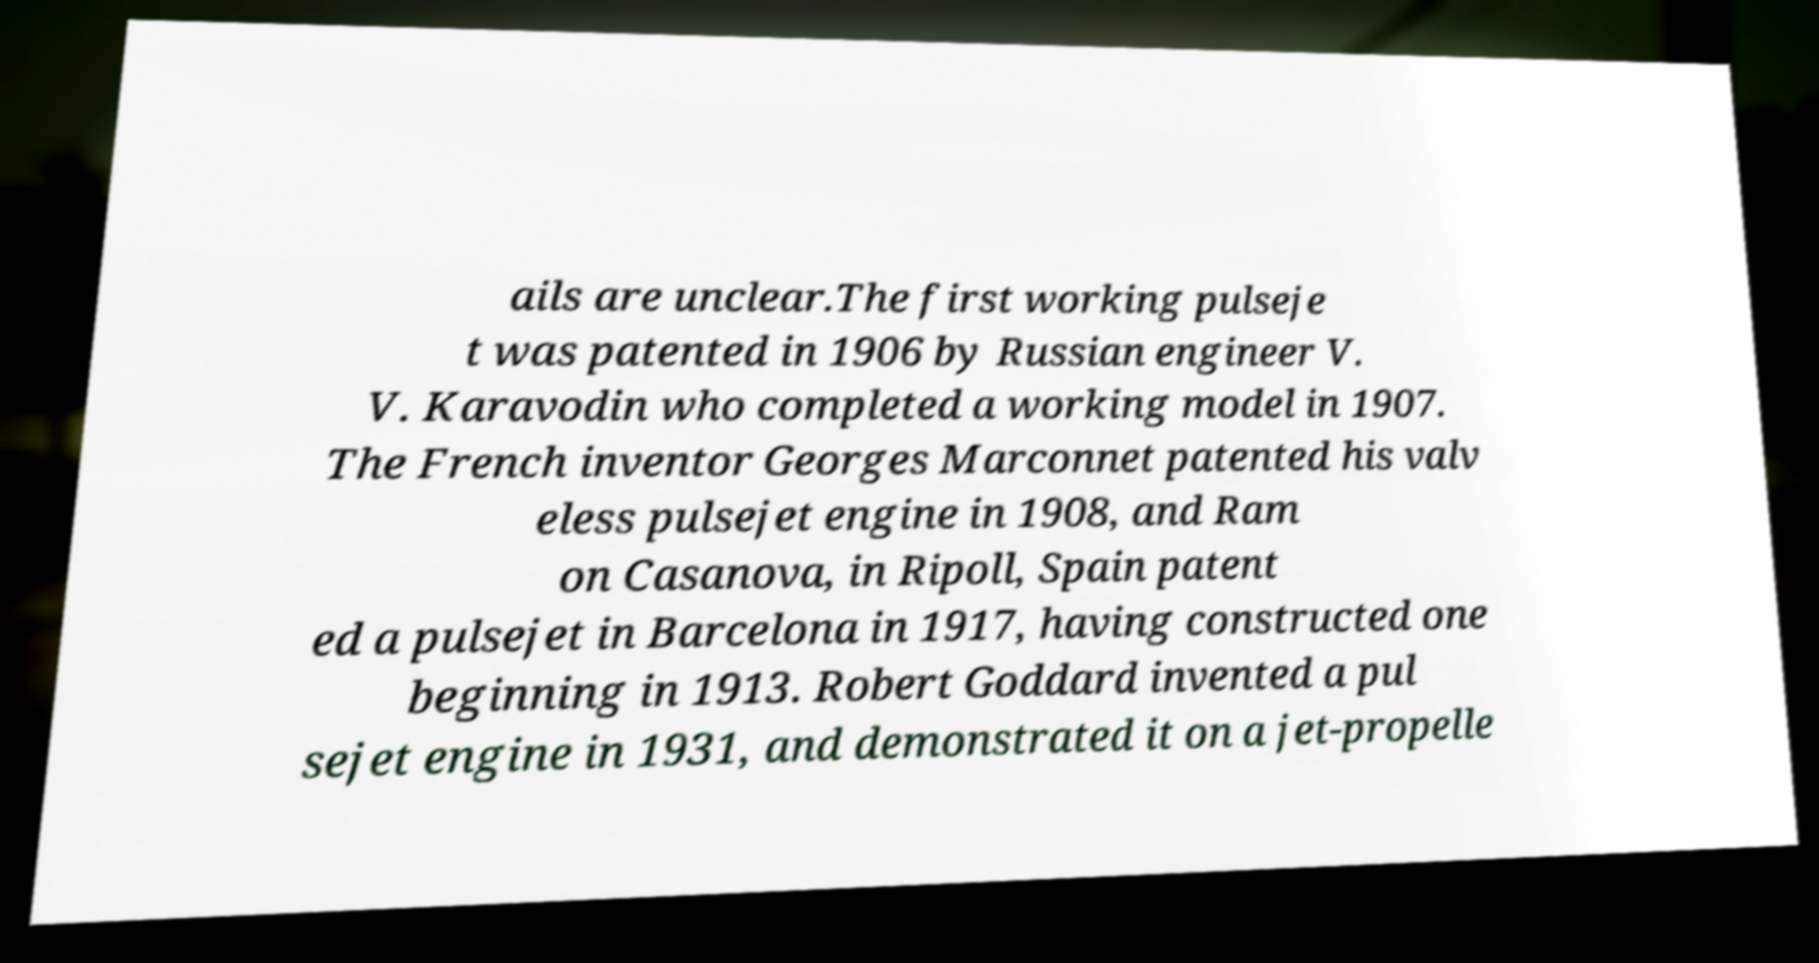For documentation purposes, I need the text within this image transcribed. Could you provide that? ails are unclear.The first working pulseje t was patented in 1906 by Russian engineer V. V. Karavodin who completed a working model in 1907. The French inventor Georges Marconnet patented his valv eless pulsejet engine in 1908, and Ram on Casanova, in Ripoll, Spain patent ed a pulsejet in Barcelona in 1917, having constructed one beginning in 1913. Robert Goddard invented a pul sejet engine in 1931, and demonstrated it on a jet-propelle 